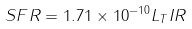Convert formula to latex. <formula><loc_0><loc_0><loc_500><loc_500>S F R = 1 . 7 1 \times 1 0 ^ { - 1 0 } L _ { T } I R</formula> 